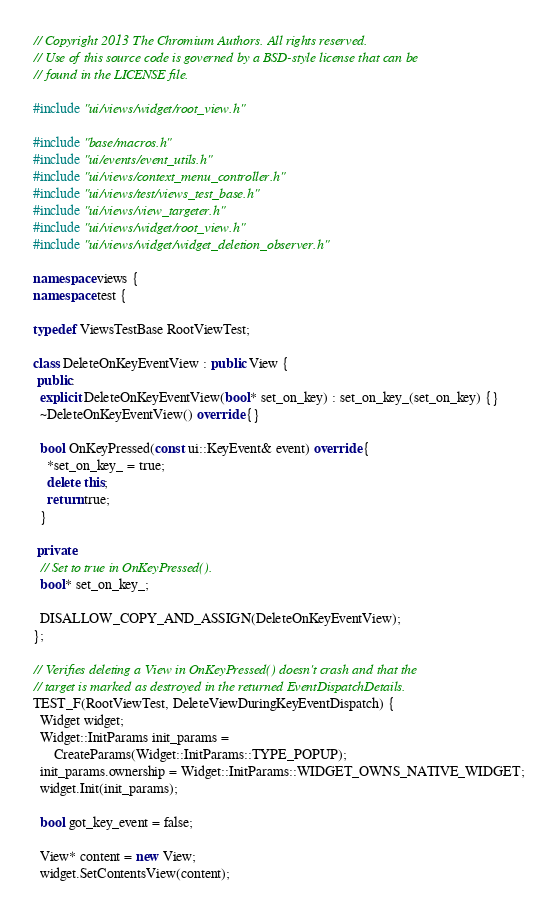<code> <loc_0><loc_0><loc_500><loc_500><_C++_>// Copyright 2013 The Chromium Authors. All rights reserved.
// Use of this source code is governed by a BSD-style license that can be
// found in the LICENSE file.

#include "ui/views/widget/root_view.h"

#include "base/macros.h"
#include "ui/events/event_utils.h"
#include "ui/views/context_menu_controller.h"
#include "ui/views/test/views_test_base.h"
#include "ui/views/view_targeter.h"
#include "ui/views/widget/root_view.h"
#include "ui/views/widget/widget_deletion_observer.h"

namespace views {
namespace test {

typedef ViewsTestBase RootViewTest;

class DeleteOnKeyEventView : public View {
 public:
  explicit DeleteOnKeyEventView(bool* set_on_key) : set_on_key_(set_on_key) {}
  ~DeleteOnKeyEventView() override {}

  bool OnKeyPressed(const ui::KeyEvent& event) override {
    *set_on_key_ = true;
    delete this;
    return true;
  }

 private:
  // Set to true in OnKeyPressed().
  bool* set_on_key_;

  DISALLOW_COPY_AND_ASSIGN(DeleteOnKeyEventView);
};

// Verifies deleting a View in OnKeyPressed() doesn't crash and that the
// target is marked as destroyed in the returned EventDispatchDetails.
TEST_F(RootViewTest, DeleteViewDuringKeyEventDispatch) {
  Widget widget;
  Widget::InitParams init_params =
      CreateParams(Widget::InitParams::TYPE_POPUP);
  init_params.ownership = Widget::InitParams::WIDGET_OWNS_NATIVE_WIDGET;
  widget.Init(init_params);

  bool got_key_event = false;

  View* content = new View;
  widget.SetContentsView(content);
</code> 